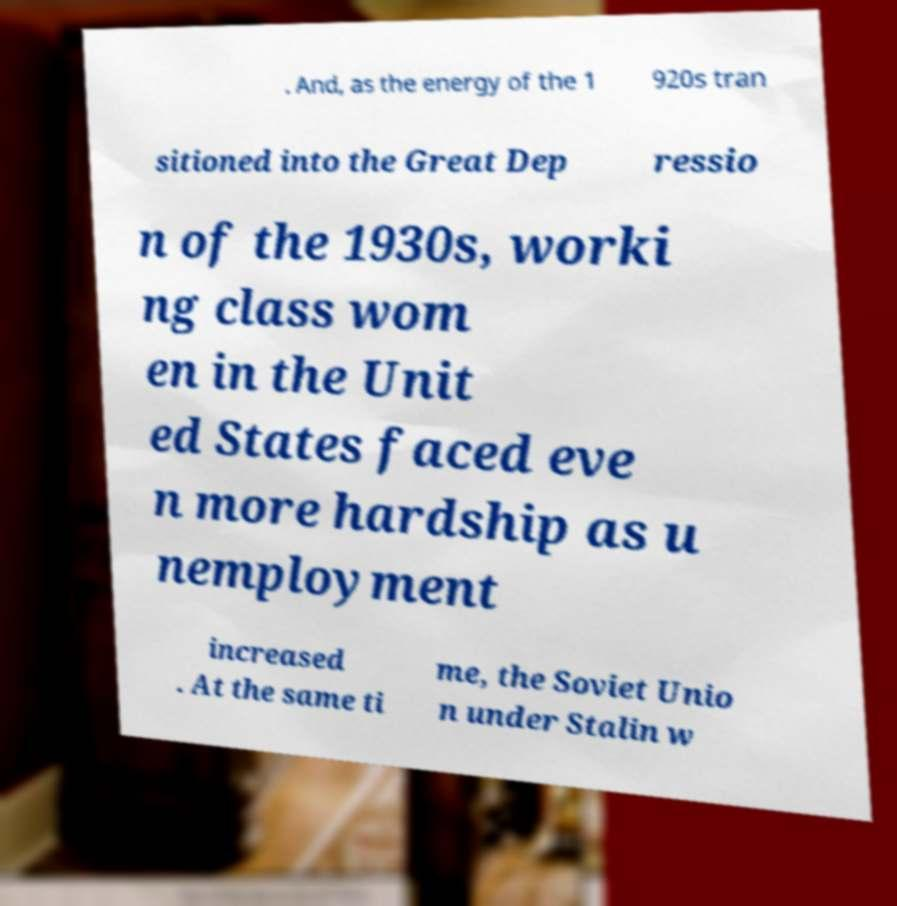There's text embedded in this image that I need extracted. Can you transcribe it verbatim? . And, as the energy of the 1 920s tran sitioned into the Great Dep ressio n of the 1930s, worki ng class wom en in the Unit ed States faced eve n more hardship as u nemployment increased . At the same ti me, the Soviet Unio n under Stalin w 